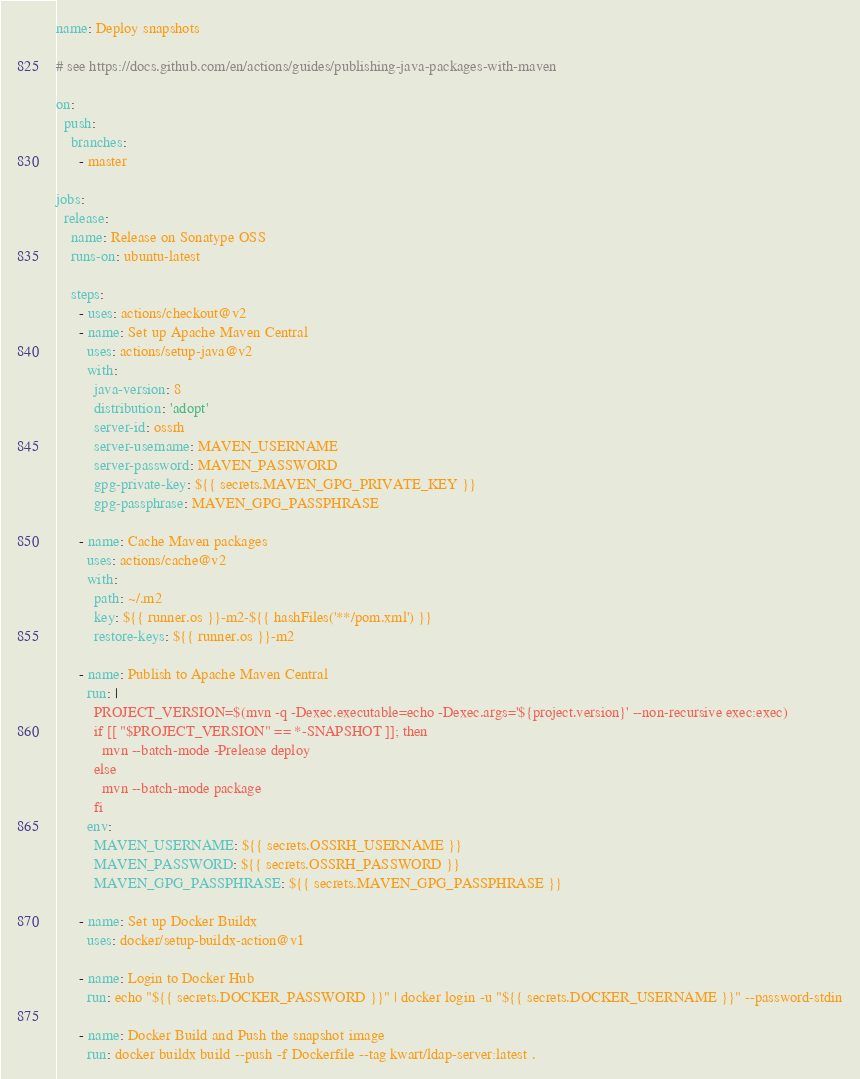<code> <loc_0><loc_0><loc_500><loc_500><_YAML_>name: Deploy snapshots

# see https://docs.github.com/en/actions/guides/publishing-java-packages-with-maven

on:
  push:
    branches:
      - master

jobs:
  release:
    name: Release on Sonatype OSS
    runs-on: ubuntu-latest

    steps:
      - uses: actions/checkout@v2
      - name: Set up Apache Maven Central
        uses: actions/setup-java@v2
        with:
          java-version: 8
          distribution: 'adopt'
          server-id: ossrh
          server-username: MAVEN_USERNAME
          server-password: MAVEN_PASSWORD
          gpg-private-key: ${{ secrets.MAVEN_GPG_PRIVATE_KEY }}
          gpg-passphrase: MAVEN_GPG_PASSPHRASE

      - name: Cache Maven packages
        uses: actions/cache@v2
        with:
          path: ~/.m2
          key: ${{ runner.os }}-m2-${{ hashFiles('**/pom.xml') }}
          restore-keys: ${{ runner.os }}-m2

      - name: Publish to Apache Maven Central
        run: |
          PROJECT_VERSION=$(mvn -q -Dexec.executable=echo -Dexec.args='${project.version}' --non-recursive exec:exec)
          if [[ "$PROJECT_VERSION" == *-SNAPSHOT ]]; then
            mvn --batch-mode -Prelease deploy
          else
            mvn --batch-mode package
          fi
        env:
          MAVEN_USERNAME: ${{ secrets.OSSRH_USERNAME }}
          MAVEN_PASSWORD: ${{ secrets.OSSRH_PASSWORD }}
          MAVEN_GPG_PASSPHRASE: ${{ secrets.MAVEN_GPG_PASSPHRASE }}

      - name: Set up Docker Buildx
        uses: docker/setup-buildx-action@v1

      - name: Login to Docker Hub
        run: echo "${{ secrets.DOCKER_PASSWORD }}" | docker login -u "${{ secrets.DOCKER_USERNAME }}" --password-stdin

      - name: Docker Build and Push the snapshot image
        run: docker buildx build --push -f Dockerfile --tag kwart/ldap-server:latest .
</code> 